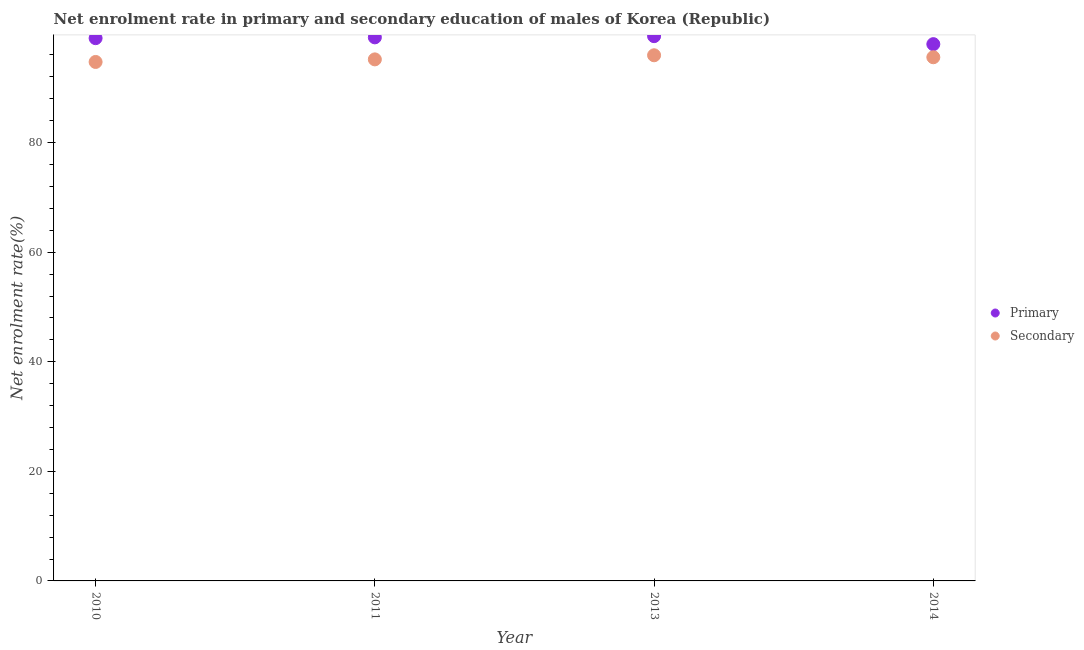What is the enrollment rate in primary education in 2010?
Your answer should be very brief. 99.07. Across all years, what is the maximum enrollment rate in primary education?
Offer a terse response. 99.44. Across all years, what is the minimum enrollment rate in primary education?
Offer a very short reply. 97.98. In which year was the enrollment rate in primary education minimum?
Ensure brevity in your answer.  2014. What is the total enrollment rate in secondary education in the graph?
Ensure brevity in your answer.  381.46. What is the difference between the enrollment rate in primary education in 2011 and that in 2013?
Your answer should be compact. -0.22. What is the difference between the enrollment rate in secondary education in 2011 and the enrollment rate in primary education in 2010?
Provide a short and direct response. -3.87. What is the average enrollment rate in secondary education per year?
Give a very brief answer. 95.37. In the year 2013, what is the difference between the enrollment rate in primary education and enrollment rate in secondary education?
Provide a short and direct response. 3.49. What is the ratio of the enrollment rate in secondary education in 2010 to that in 2013?
Your response must be concise. 0.99. Is the difference between the enrollment rate in secondary education in 2010 and 2013 greater than the difference between the enrollment rate in primary education in 2010 and 2013?
Your response must be concise. No. What is the difference between the highest and the second highest enrollment rate in secondary education?
Your response must be concise. 0.36. What is the difference between the highest and the lowest enrollment rate in primary education?
Keep it short and to the point. 1.46. In how many years, is the enrollment rate in secondary education greater than the average enrollment rate in secondary education taken over all years?
Offer a very short reply. 2. Is the sum of the enrollment rate in secondary education in 2011 and 2013 greater than the maximum enrollment rate in primary education across all years?
Your answer should be very brief. Yes. Does the enrollment rate in secondary education monotonically increase over the years?
Ensure brevity in your answer.  No. Is the enrollment rate in secondary education strictly less than the enrollment rate in primary education over the years?
Provide a short and direct response. Yes. How many years are there in the graph?
Make the answer very short. 4. What is the difference between two consecutive major ticks on the Y-axis?
Provide a short and direct response. 20. Are the values on the major ticks of Y-axis written in scientific E-notation?
Your answer should be very brief. No. Does the graph contain any zero values?
Provide a short and direct response. No. How are the legend labels stacked?
Make the answer very short. Vertical. What is the title of the graph?
Provide a succinct answer. Net enrolment rate in primary and secondary education of males of Korea (Republic). Does "Exports of goods" appear as one of the legend labels in the graph?
Ensure brevity in your answer.  No. What is the label or title of the Y-axis?
Ensure brevity in your answer.  Net enrolment rate(%). What is the Net enrolment rate(%) of Primary in 2010?
Offer a very short reply. 99.07. What is the Net enrolment rate(%) in Secondary in 2010?
Your answer should be compact. 94.73. What is the Net enrolment rate(%) in Primary in 2011?
Offer a very short reply. 99.22. What is the Net enrolment rate(%) of Secondary in 2011?
Offer a very short reply. 95.2. What is the Net enrolment rate(%) in Primary in 2013?
Ensure brevity in your answer.  99.44. What is the Net enrolment rate(%) in Secondary in 2013?
Make the answer very short. 95.95. What is the Net enrolment rate(%) of Primary in 2014?
Provide a short and direct response. 97.98. What is the Net enrolment rate(%) of Secondary in 2014?
Offer a terse response. 95.59. Across all years, what is the maximum Net enrolment rate(%) of Primary?
Give a very brief answer. 99.44. Across all years, what is the maximum Net enrolment rate(%) in Secondary?
Give a very brief answer. 95.95. Across all years, what is the minimum Net enrolment rate(%) of Primary?
Offer a terse response. 97.98. Across all years, what is the minimum Net enrolment rate(%) of Secondary?
Keep it short and to the point. 94.73. What is the total Net enrolment rate(%) in Primary in the graph?
Offer a very short reply. 395.7. What is the total Net enrolment rate(%) of Secondary in the graph?
Your response must be concise. 381.46. What is the difference between the Net enrolment rate(%) in Primary in 2010 and that in 2011?
Your answer should be compact. -0.15. What is the difference between the Net enrolment rate(%) in Secondary in 2010 and that in 2011?
Offer a terse response. -0.47. What is the difference between the Net enrolment rate(%) of Primary in 2010 and that in 2013?
Offer a terse response. -0.37. What is the difference between the Net enrolment rate(%) of Secondary in 2010 and that in 2013?
Provide a short and direct response. -1.22. What is the difference between the Net enrolment rate(%) in Primary in 2010 and that in 2014?
Provide a succinct answer. 1.09. What is the difference between the Net enrolment rate(%) in Secondary in 2010 and that in 2014?
Offer a terse response. -0.86. What is the difference between the Net enrolment rate(%) of Primary in 2011 and that in 2013?
Give a very brief answer. -0.22. What is the difference between the Net enrolment rate(%) in Secondary in 2011 and that in 2013?
Offer a very short reply. -0.75. What is the difference between the Net enrolment rate(%) in Primary in 2011 and that in 2014?
Provide a short and direct response. 1.24. What is the difference between the Net enrolment rate(%) in Secondary in 2011 and that in 2014?
Your answer should be compact. -0.39. What is the difference between the Net enrolment rate(%) of Primary in 2013 and that in 2014?
Provide a succinct answer. 1.46. What is the difference between the Net enrolment rate(%) in Secondary in 2013 and that in 2014?
Your response must be concise. 0.36. What is the difference between the Net enrolment rate(%) of Primary in 2010 and the Net enrolment rate(%) of Secondary in 2011?
Your answer should be very brief. 3.87. What is the difference between the Net enrolment rate(%) of Primary in 2010 and the Net enrolment rate(%) of Secondary in 2013?
Your answer should be compact. 3.12. What is the difference between the Net enrolment rate(%) of Primary in 2010 and the Net enrolment rate(%) of Secondary in 2014?
Offer a very short reply. 3.48. What is the difference between the Net enrolment rate(%) of Primary in 2011 and the Net enrolment rate(%) of Secondary in 2013?
Offer a terse response. 3.27. What is the difference between the Net enrolment rate(%) of Primary in 2011 and the Net enrolment rate(%) of Secondary in 2014?
Your answer should be very brief. 3.63. What is the difference between the Net enrolment rate(%) of Primary in 2013 and the Net enrolment rate(%) of Secondary in 2014?
Keep it short and to the point. 3.85. What is the average Net enrolment rate(%) in Primary per year?
Give a very brief answer. 98.93. What is the average Net enrolment rate(%) of Secondary per year?
Your response must be concise. 95.37. In the year 2010, what is the difference between the Net enrolment rate(%) of Primary and Net enrolment rate(%) of Secondary?
Your answer should be very brief. 4.34. In the year 2011, what is the difference between the Net enrolment rate(%) of Primary and Net enrolment rate(%) of Secondary?
Your answer should be very brief. 4.02. In the year 2013, what is the difference between the Net enrolment rate(%) of Primary and Net enrolment rate(%) of Secondary?
Your answer should be compact. 3.49. In the year 2014, what is the difference between the Net enrolment rate(%) in Primary and Net enrolment rate(%) in Secondary?
Provide a short and direct response. 2.39. What is the ratio of the Net enrolment rate(%) of Secondary in 2010 to that in 2013?
Your answer should be very brief. 0.99. What is the ratio of the Net enrolment rate(%) in Primary in 2010 to that in 2014?
Provide a short and direct response. 1.01. What is the ratio of the Net enrolment rate(%) in Secondary in 2010 to that in 2014?
Offer a very short reply. 0.99. What is the ratio of the Net enrolment rate(%) of Primary in 2011 to that in 2013?
Provide a succinct answer. 1. What is the ratio of the Net enrolment rate(%) in Secondary in 2011 to that in 2013?
Provide a short and direct response. 0.99. What is the ratio of the Net enrolment rate(%) in Primary in 2011 to that in 2014?
Offer a terse response. 1.01. What is the ratio of the Net enrolment rate(%) of Primary in 2013 to that in 2014?
Keep it short and to the point. 1.01. What is the ratio of the Net enrolment rate(%) in Secondary in 2013 to that in 2014?
Make the answer very short. 1. What is the difference between the highest and the second highest Net enrolment rate(%) in Primary?
Keep it short and to the point. 0.22. What is the difference between the highest and the second highest Net enrolment rate(%) of Secondary?
Your answer should be compact. 0.36. What is the difference between the highest and the lowest Net enrolment rate(%) of Primary?
Keep it short and to the point. 1.46. What is the difference between the highest and the lowest Net enrolment rate(%) of Secondary?
Offer a terse response. 1.22. 